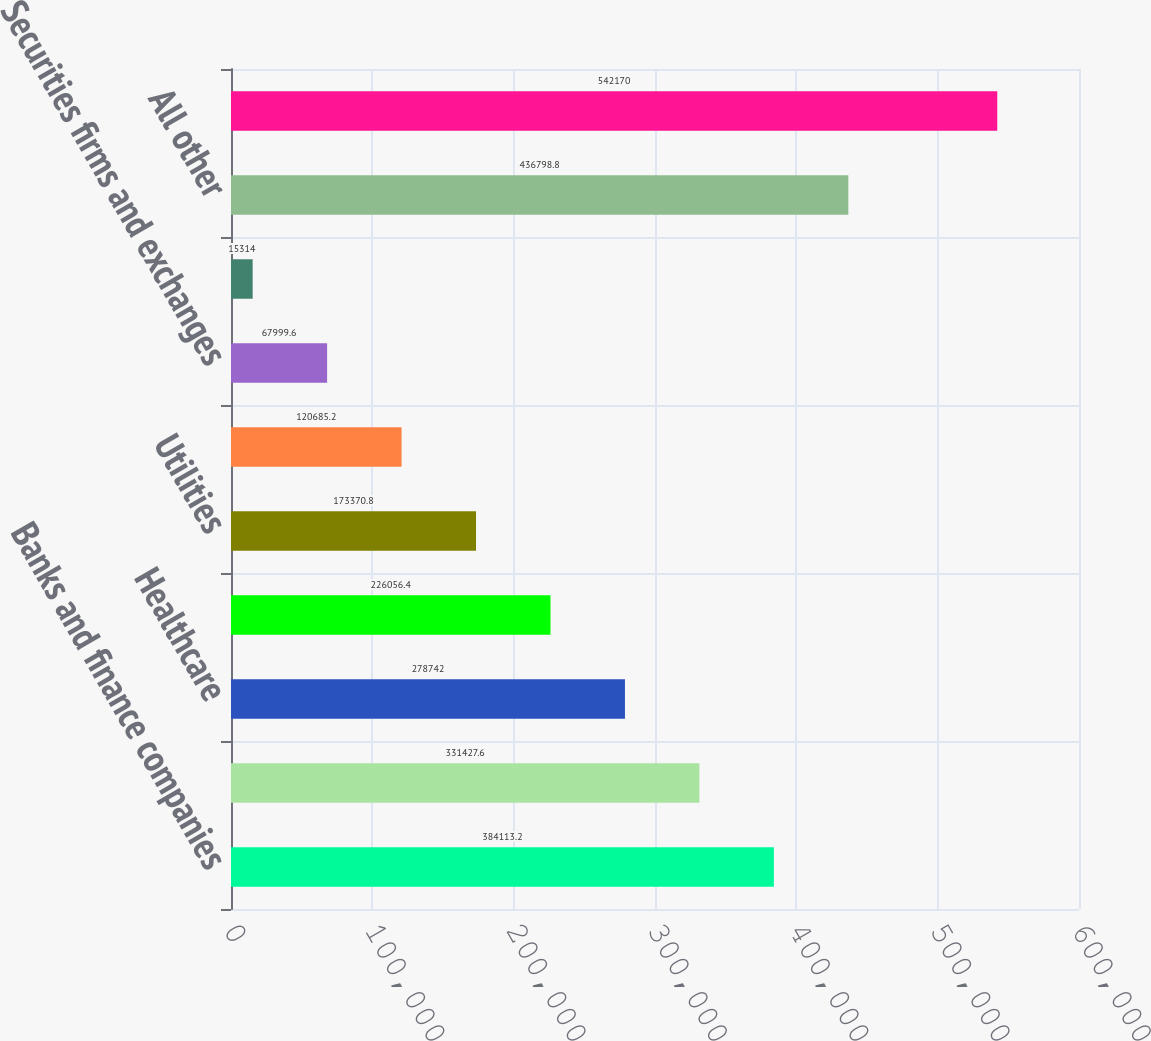<chart> <loc_0><loc_0><loc_500><loc_500><bar_chart><fcel>Banks and finance companies<fcel>Real estate<fcel>Healthcare<fcel>Consumer products<fcel>Utilities<fcel>Asset managers<fcel>Securities firms and exchanges<fcel>Media<fcel>All other<fcel>Total<nl><fcel>384113<fcel>331428<fcel>278742<fcel>226056<fcel>173371<fcel>120685<fcel>67999.6<fcel>15314<fcel>436799<fcel>542170<nl></chart> 